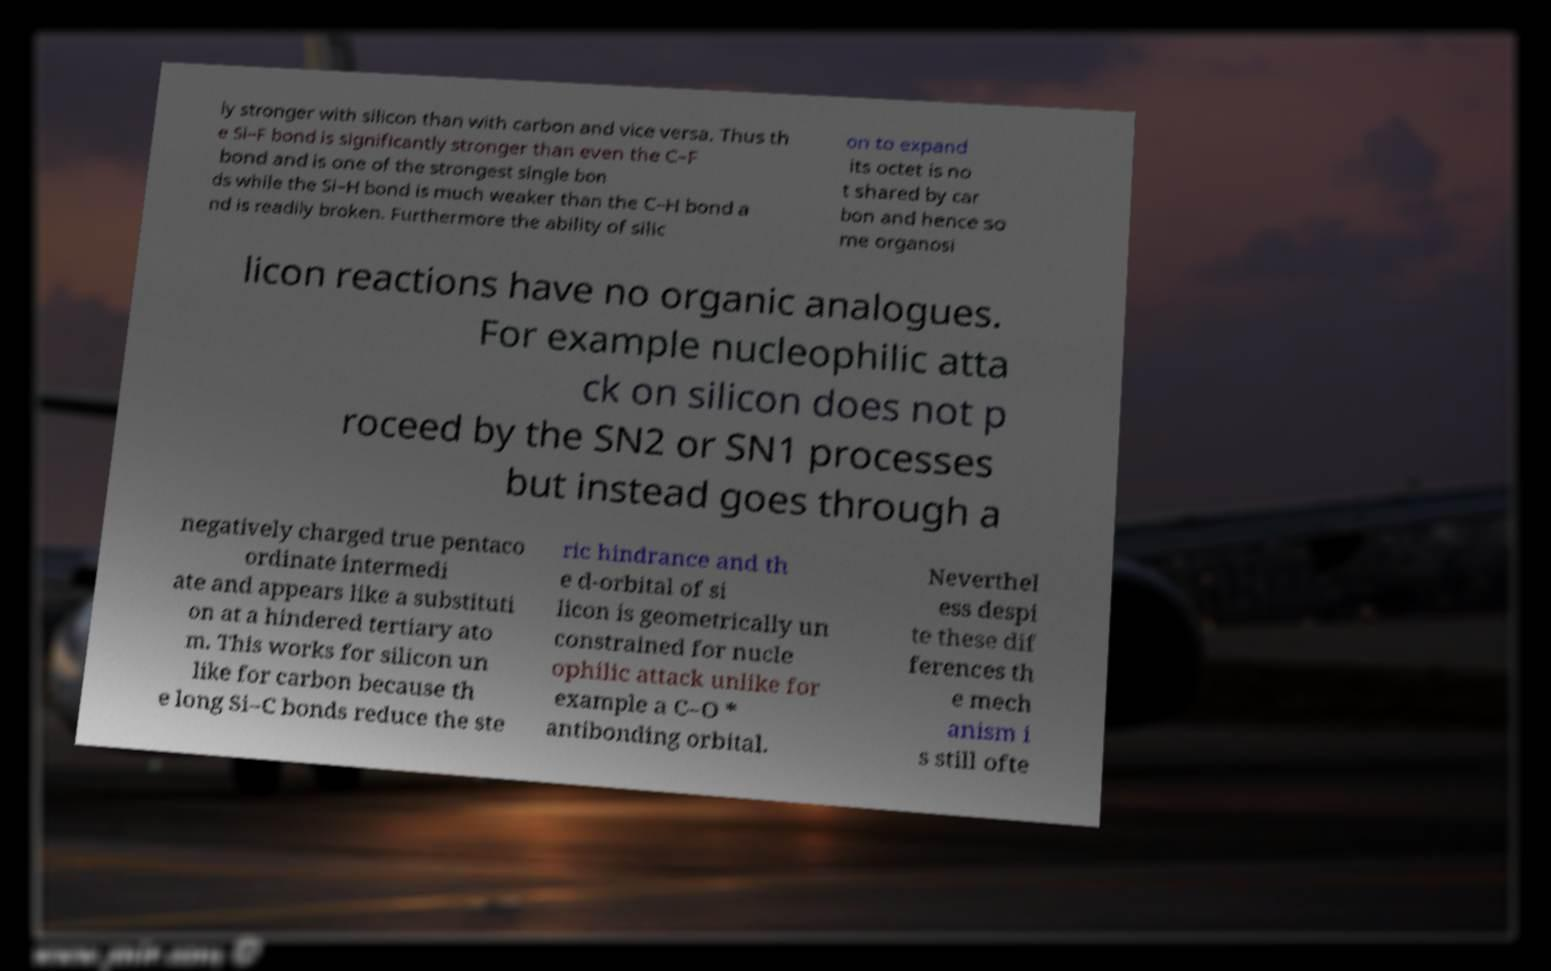Could you extract and type out the text from this image? ly stronger with silicon than with carbon and vice versa. Thus th e Si–F bond is significantly stronger than even the C–F bond and is one of the strongest single bon ds while the Si–H bond is much weaker than the C–H bond a nd is readily broken. Furthermore the ability of silic on to expand its octet is no t shared by car bon and hence so me organosi licon reactions have no organic analogues. For example nucleophilic atta ck on silicon does not p roceed by the SN2 or SN1 processes but instead goes through a negatively charged true pentaco ordinate intermedi ate and appears like a substituti on at a hindered tertiary ato m. This works for silicon un like for carbon because th e long Si–C bonds reduce the ste ric hindrance and th e d-orbital of si licon is geometrically un constrained for nucle ophilic attack unlike for example a C–O * antibonding orbital. Neverthel ess despi te these dif ferences th e mech anism i s still ofte 